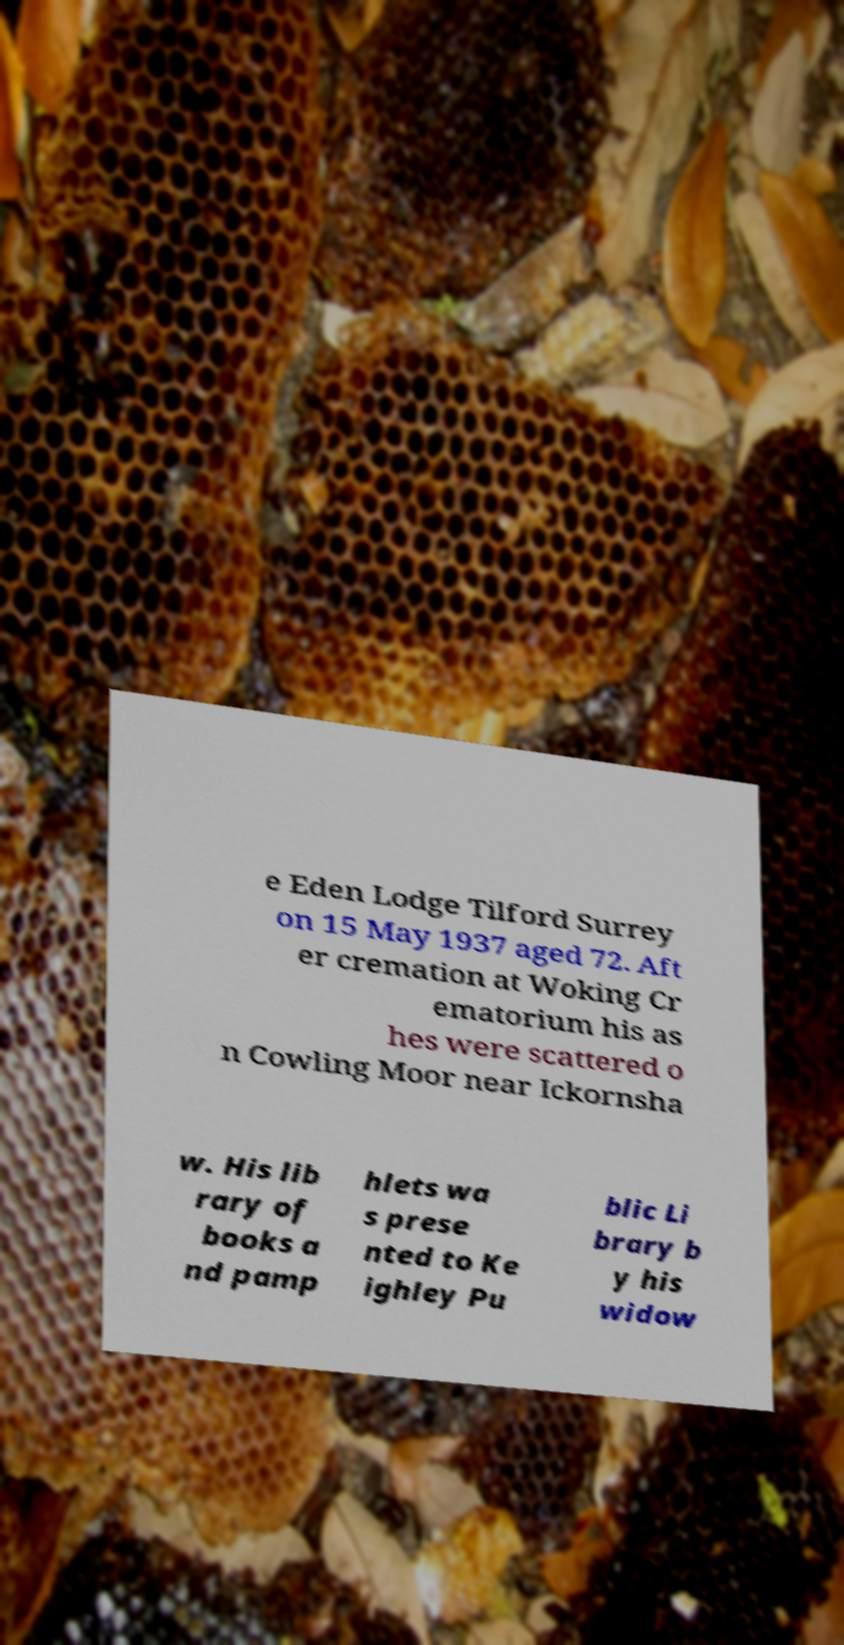Can you read and provide the text displayed in the image?This photo seems to have some interesting text. Can you extract and type it out for me? e Eden Lodge Tilford Surrey on 15 May 1937 aged 72. Aft er cremation at Woking Cr ematorium his as hes were scattered o n Cowling Moor near Ickornsha w. His lib rary of books a nd pamp hlets wa s prese nted to Ke ighley Pu blic Li brary b y his widow 